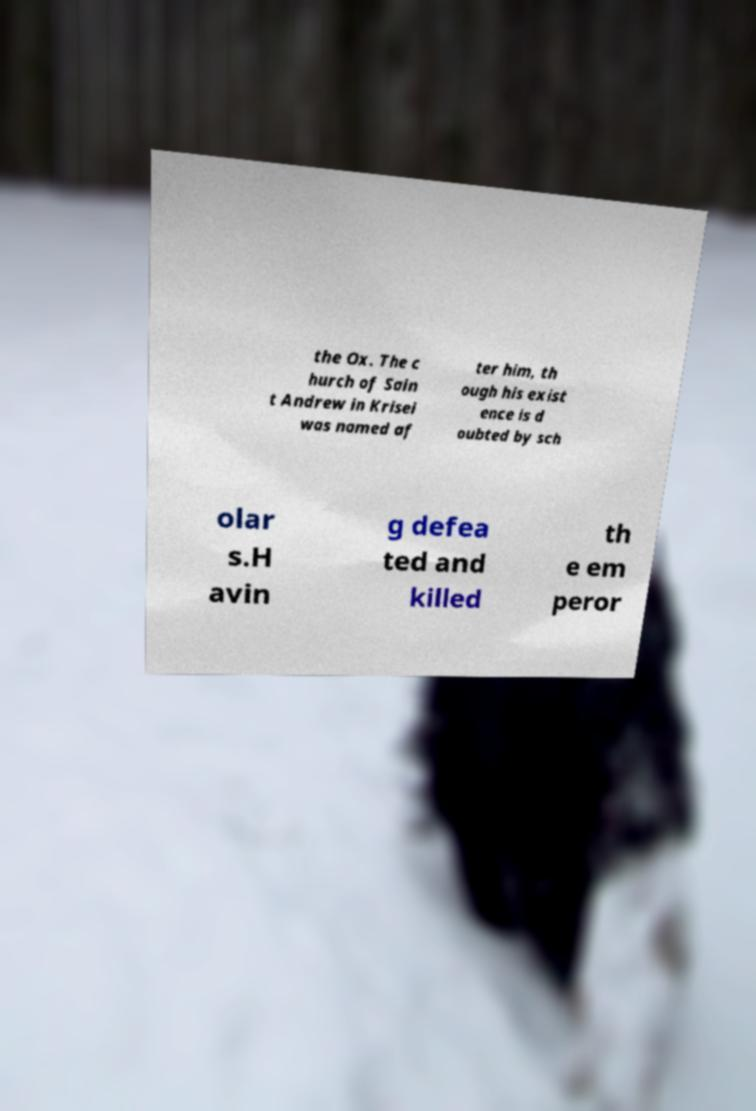What messages or text are displayed in this image? I need them in a readable, typed format. the Ox. The c hurch of Sain t Andrew in Krisei was named af ter him, th ough his exist ence is d oubted by sch olar s.H avin g defea ted and killed th e em peror 